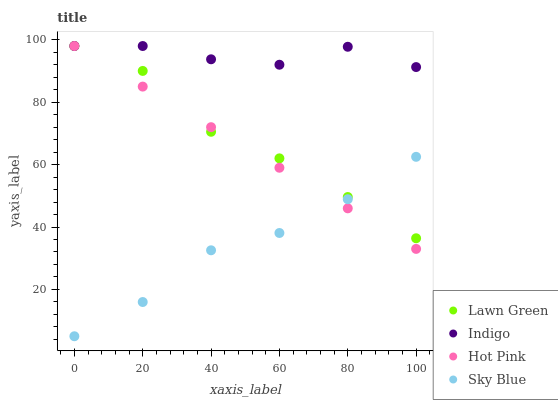Does Sky Blue have the minimum area under the curve?
Answer yes or no. Yes. Does Indigo have the maximum area under the curve?
Answer yes or no. Yes. Does Hot Pink have the minimum area under the curve?
Answer yes or no. No. Does Hot Pink have the maximum area under the curve?
Answer yes or no. No. Is Hot Pink the smoothest?
Answer yes or no. Yes. Is Lawn Green the roughest?
Answer yes or no. Yes. Is Indigo the smoothest?
Answer yes or no. No. Is Indigo the roughest?
Answer yes or no. No. Does Sky Blue have the lowest value?
Answer yes or no. Yes. Does Hot Pink have the lowest value?
Answer yes or no. No. Does Indigo have the highest value?
Answer yes or no. Yes. Does Sky Blue have the highest value?
Answer yes or no. No. Is Sky Blue less than Indigo?
Answer yes or no. Yes. Is Indigo greater than Sky Blue?
Answer yes or no. Yes. Does Indigo intersect Hot Pink?
Answer yes or no. Yes. Is Indigo less than Hot Pink?
Answer yes or no. No. Is Indigo greater than Hot Pink?
Answer yes or no. No. Does Sky Blue intersect Indigo?
Answer yes or no. No. 